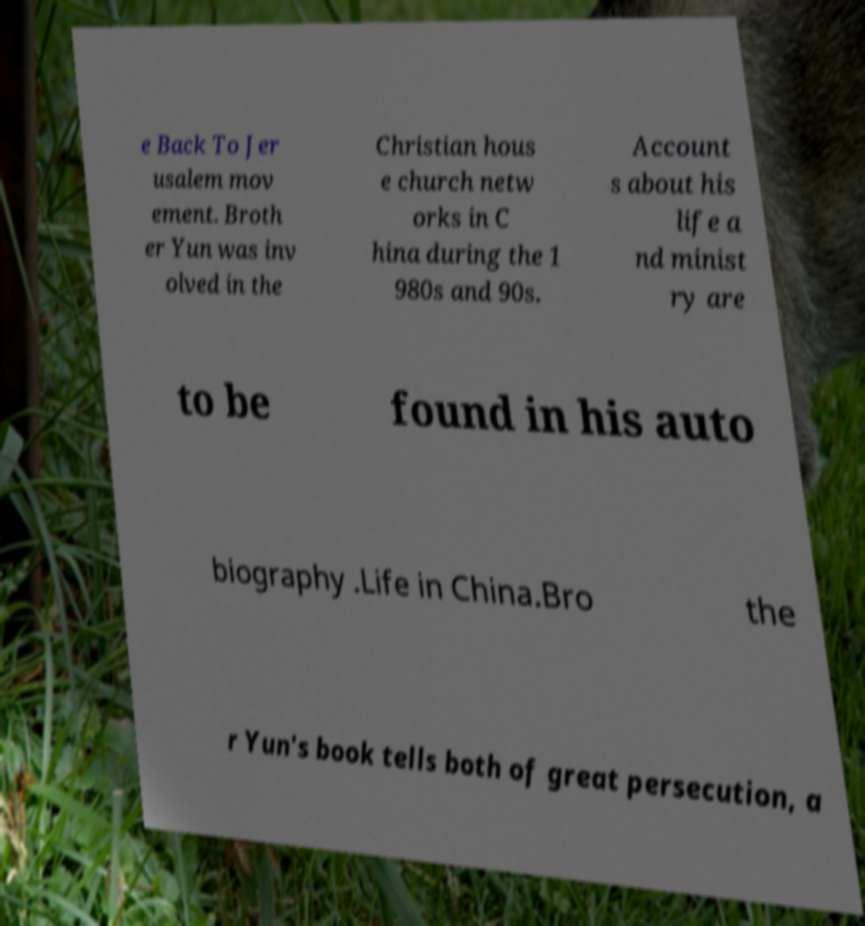What messages or text are displayed in this image? I need them in a readable, typed format. e Back To Jer usalem mov ement. Broth er Yun was inv olved in the Christian hous e church netw orks in C hina during the 1 980s and 90s. Account s about his life a nd minist ry are to be found in his auto biography .Life in China.Bro the r Yun's book tells both of great persecution, a 